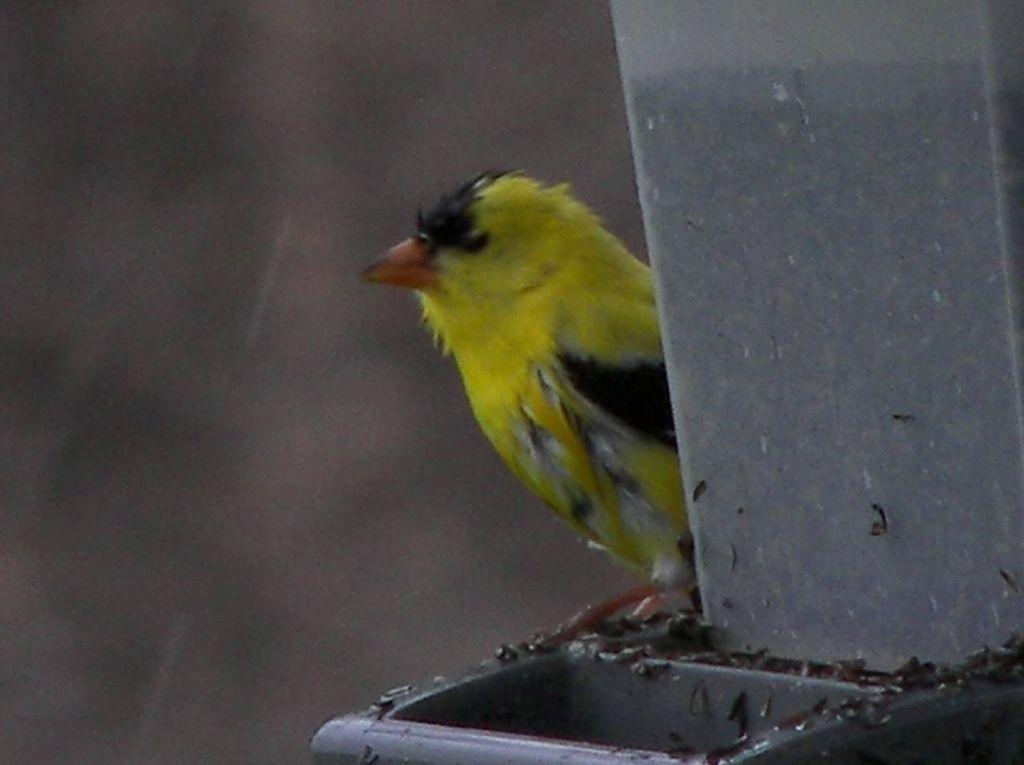What type of animal is in the image? There is a bird in the image. Where is the bird located? The bird is on a pole. What type of square is holding the bird in the image? There is no square present in the image; the bird is on a pole. What kind of agreement does the bird have with the net in the image? There is no net present in the image, and therefore no agreement can be discussed. 